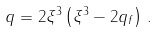Convert formula to latex. <formula><loc_0><loc_0><loc_500><loc_500>q = 2 \xi ^ { 3 } \left ( \xi ^ { 3 } - 2 q _ { f } \right ) \, .</formula> 